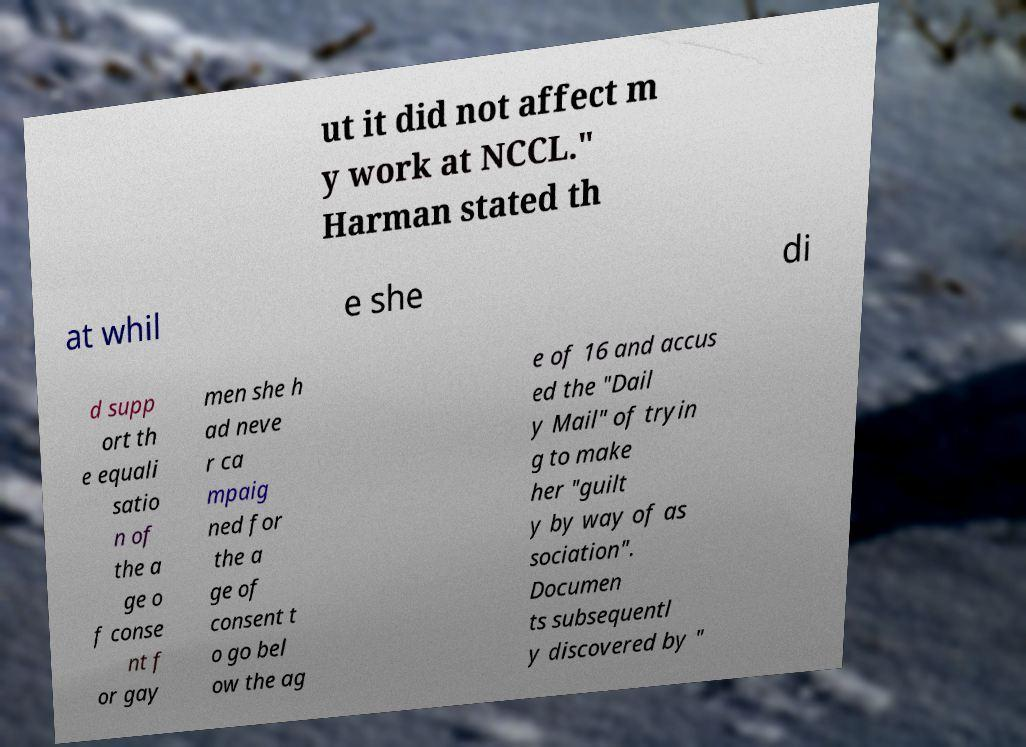Could you assist in decoding the text presented in this image and type it out clearly? ut it did not affect m y work at NCCL." Harman stated th at whil e she di d supp ort th e equali satio n of the a ge o f conse nt f or gay men she h ad neve r ca mpaig ned for the a ge of consent t o go bel ow the ag e of 16 and accus ed the "Dail y Mail" of tryin g to make her "guilt y by way of as sociation". Documen ts subsequentl y discovered by " 